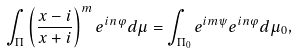Convert formula to latex. <formula><loc_0><loc_0><loc_500><loc_500>\int _ { \Pi } \left ( \frac { x - i } { x + i } \right ) ^ { m } e ^ { i n \varphi } d \mu = \int _ { \Pi _ { 0 } } e ^ { i m \psi } e ^ { i n \varphi } d \mu _ { 0 } ,</formula> 